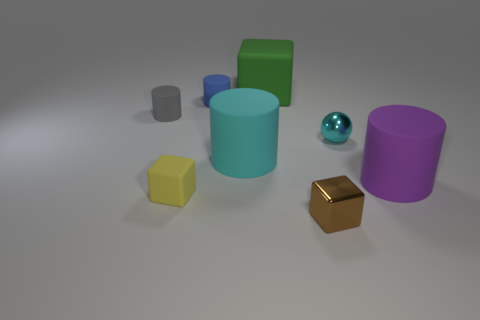Is the number of metal blocks on the left side of the gray matte cylinder greater than the number of brown things that are on the right side of the big purple rubber thing?
Your response must be concise. No. There is a large cylinder that is the same color as the small metallic ball; what material is it?
Your response must be concise. Rubber. Is there any other thing that is the same shape as the cyan shiny thing?
Your answer should be compact. No. What is the tiny object that is on the left side of the green thing and in front of the big purple matte cylinder made of?
Provide a succinct answer. Rubber. Does the small yellow object have the same material as the cylinder behind the small gray object?
Keep it short and to the point. Yes. Are there any other things that are the same size as the blue matte cylinder?
Offer a terse response. Yes. How many things are tiny gray things or things left of the tiny yellow object?
Provide a short and direct response. 1. Does the block behind the gray cylinder have the same size as the cylinder that is behind the tiny gray object?
Provide a succinct answer. No. What number of other things are the same color as the large cube?
Ensure brevity in your answer.  0. Do the purple matte object and the rubber cube that is behind the small gray cylinder have the same size?
Your answer should be compact. Yes. 